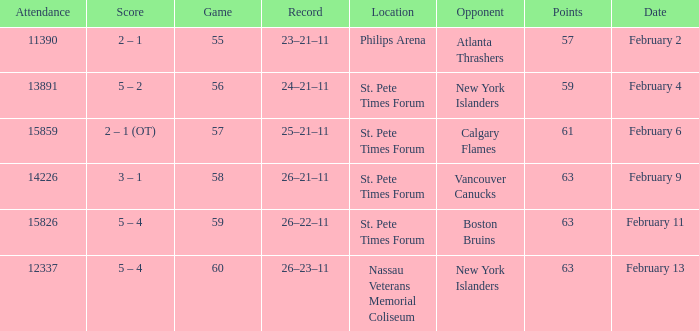Give me the full table as a dictionary. {'header': ['Attendance', 'Score', 'Game', 'Record', 'Location', 'Opponent', 'Points', 'Date'], 'rows': [['11390', '2 – 1', '55', '23–21–11', 'Philips Arena', 'Atlanta Thrashers', '57', 'February 2'], ['13891', '5 – 2', '56', '24–21–11', 'St. Pete Times Forum', 'New York Islanders', '59', 'February 4'], ['15859', '2 – 1 (OT)', '57', '25–21–11', 'St. Pete Times Forum', 'Calgary Flames', '61', 'February 6'], ['14226', '3 – 1', '58', '26–21–11', 'St. Pete Times Forum', 'Vancouver Canucks', '63', 'February 9'], ['15826', '5 – 4', '59', '26–22–11', 'St. Pete Times Forum', 'Boston Bruins', '63', 'February 11'], ['12337', '5 – 4', '60', '26–23–11', 'Nassau Veterans Memorial Coliseum', 'New York Islanders', '63', 'February 13']]} What scores happened on February 11? 5 – 4. 